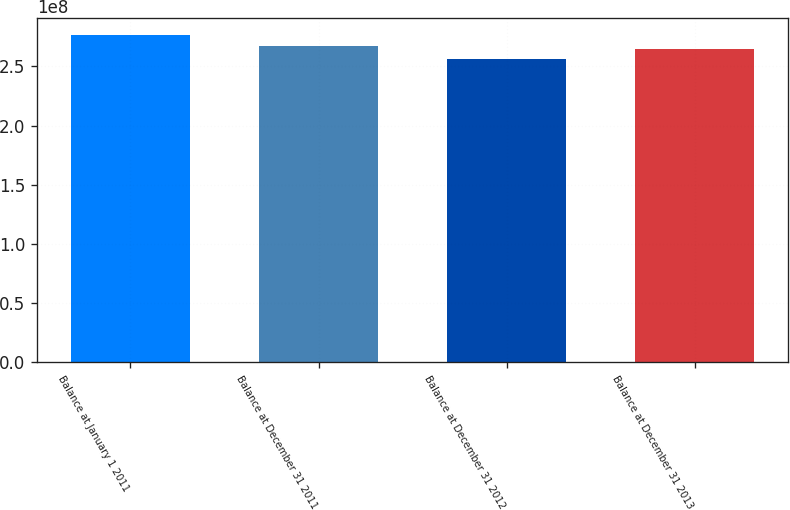<chart> <loc_0><loc_0><loc_500><loc_500><bar_chart><fcel>Balance at January 1 2011<fcel>Balance at December 31 2011<fcel>Balance at December 31 2012<fcel>Balance at December 31 2013<nl><fcel>2.77002e+08<fcel>2.67556e+08<fcel>2.56631e+08<fcel>2.64882e+08<nl></chart> 